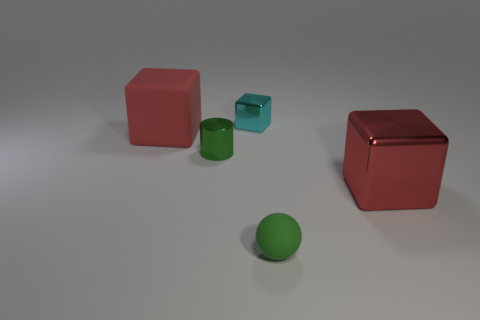Add 2 small cylinders. How many objects exist? 7 Subtract all metallic cubes. How many cubes are left? 1 Subtract all cyan blocks. How many blocks are left? 2 Subtract 0 cyan cylinders. How many objects are left? 5 Subtract all blocks. How many objects are left? 2 Subtract 1 spheres. How many spheres are left? 0 Subtract all gray balls. Subtract all blue cylinders. How many balls are left? 1 Subtract all red cylinders. How many cyan blocks are left? 1 Subtract all large cyan objects. Subtract all tiny cyan things. How many objects are left? 4 Add 4 large red shiny things. How many large red shiny things are left? 5 